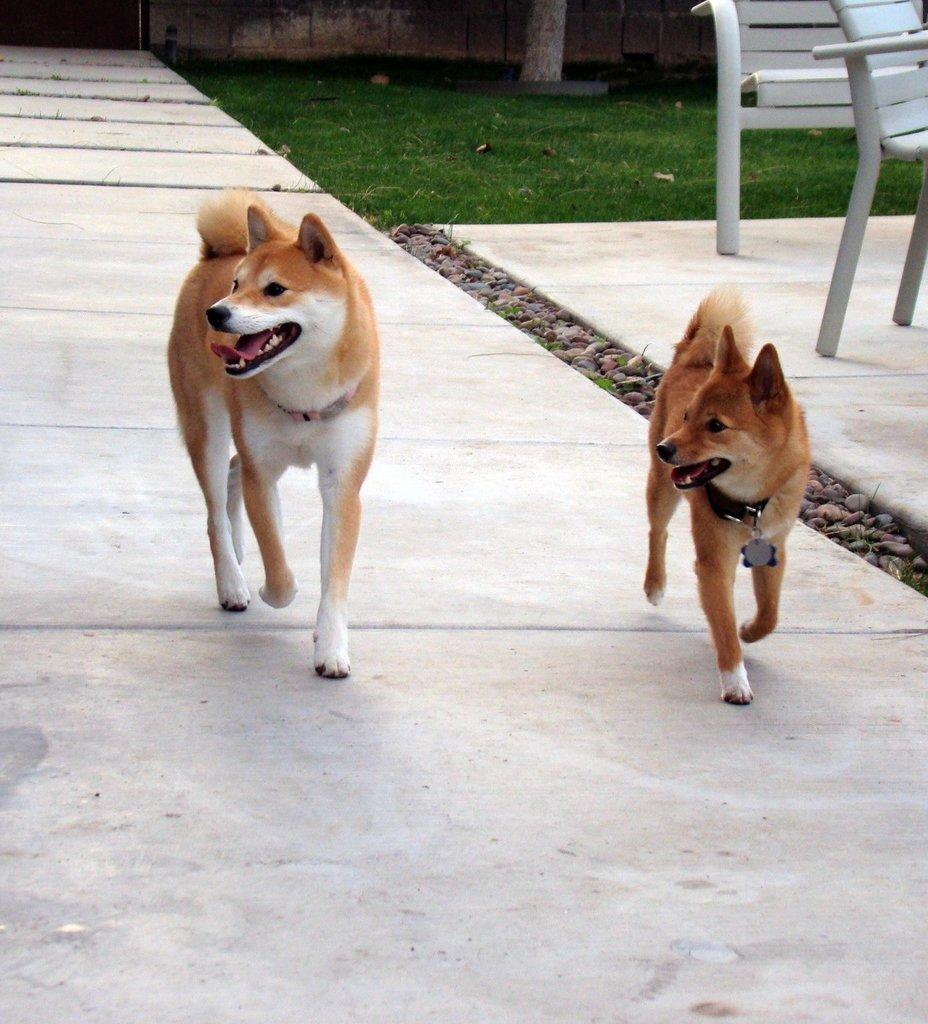How many dogs are in the picture? There are two dogs in the picture. What else can be seen in the picture besides the dogs? There are chairs and green grass in the picture. What colors are the dogs? The dogs are brown and white in color. How many snails are crawling on the neck of the donkey in the picture? There is no donkey or snails present in the image. 